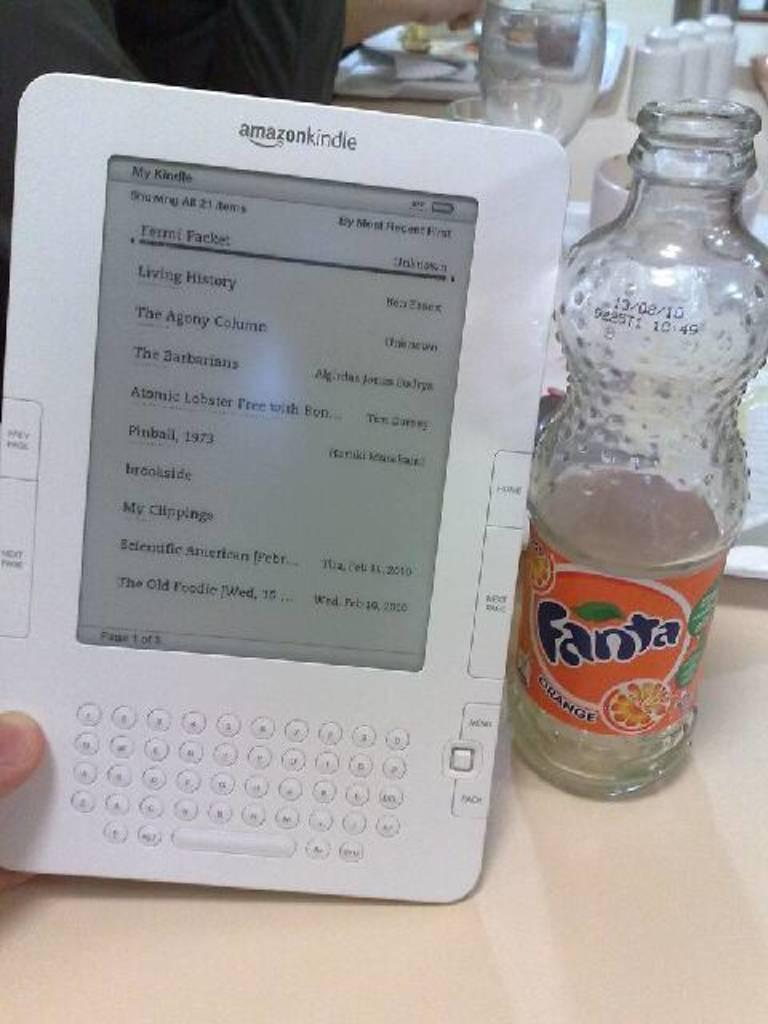<image>
Create a compact narrative representing the image presented. An Amazon Kindle reader with a list of downloaded books including The Barbarians and Living History is held next to a bottle of Fanta Orange soda. 